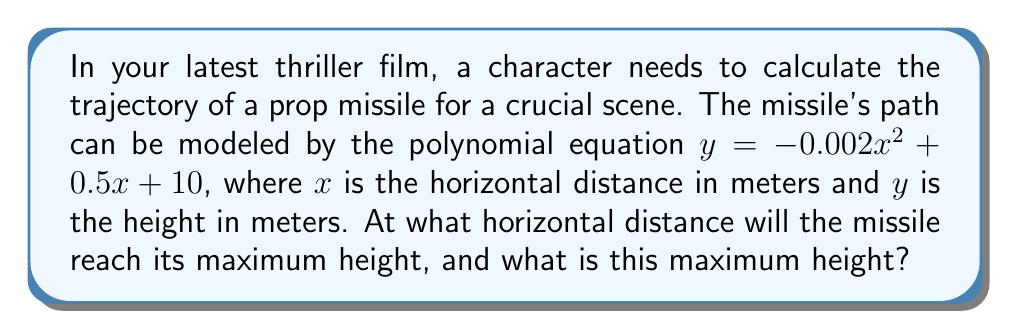Teach me how to tackle this problem. To solve this problem, we'll follow these steps:

1) The polynomial equation given is in the form of a quadratic function:
   $y = -0.002x^2 + 0.5x + 10$

2) For a quadratic function $y = ax^2 + bx + c$, the x-coordinate of the vertex (which represents the maximum or minimum point) is given by the formula:
   $x = -\frac{b}{2a}$

3) In our case, $a = -0.002$ and $b = 0.5$. Let's substitute these values:
   $x = -\frac{0.5}{2(-0.002)} = -\frac{0.5}{-0.004} = 125$

4) So, the missile reaches its maximum height at a horizontal distance of 125 meters.

5) To find the maximum height, we need to substitute this x-value back into our original equation:
   $y = -0.002(125)^2 + 0.5(125) + 10$
   $y = -0.002(15625) + 62.5 + 10$
   $y = -31.25 + 62.5 + 10$
   $y = 41.25$

Therefore, the maximum height reached by the missile is 41.25 meters.
Answer: The missile reaches its maximum height of 41.25 meters at a horizontal distance of 125 meters. 